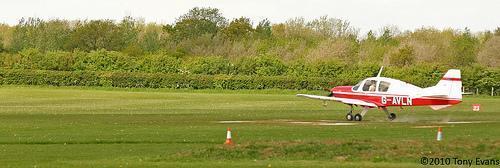How many planes are in the photo?
Give a very brief answer. 1. 